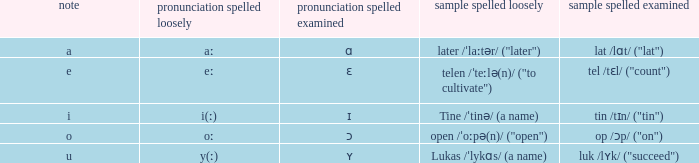What is Pronunciation Spelled Checked, when Example Spelled Checked is "tin /tɪn/ ("tin")" Ɪ. 